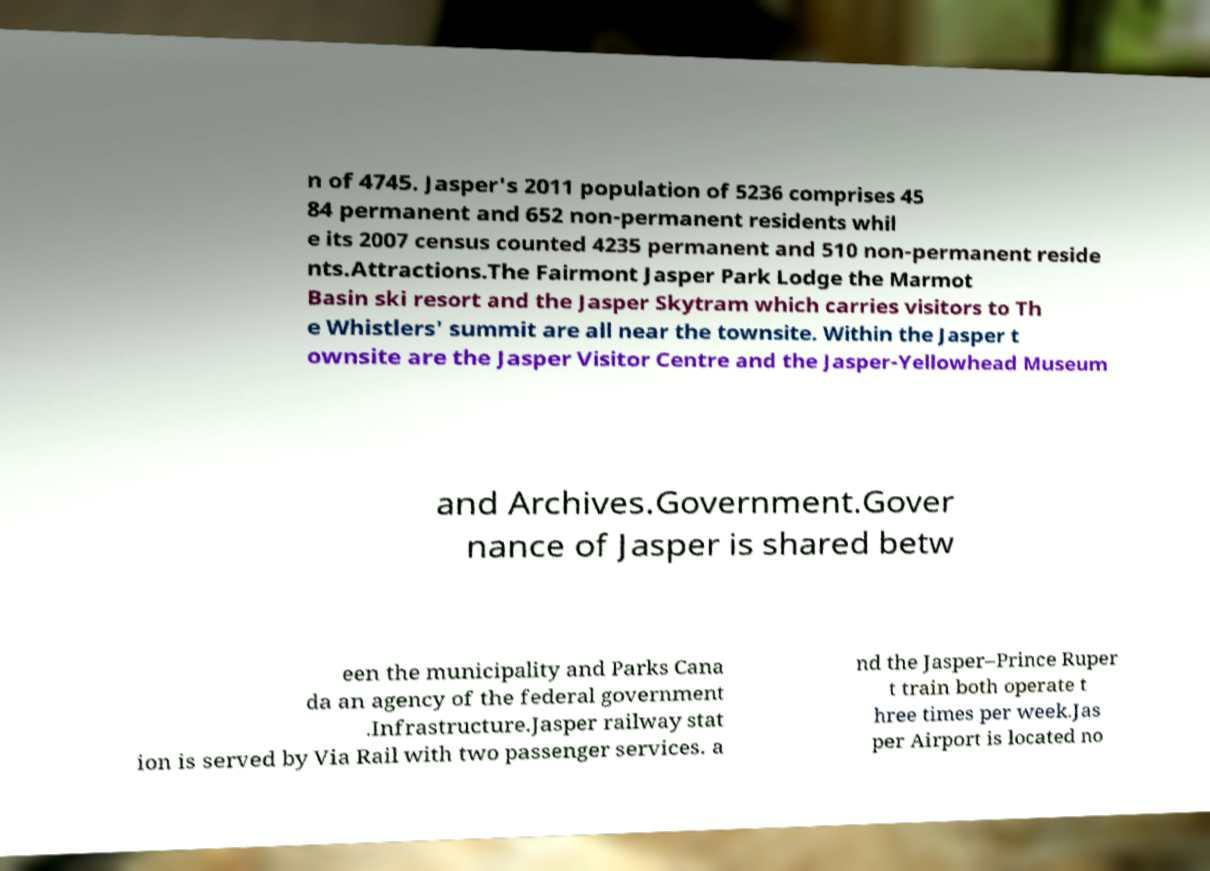What messages or text are displayed in this image? I need them in a readable, typed format. n of 4745. Jasper's 2011 population of 5236 comprises 45 84 permanent and 652 non-permanent residents whil e its 2007 census counted 4235 permanent and 510 non-permanent reside nts.Attractions.The Fairmont Jasper Park Lodge the Marmot Basin ski resort and the Jasper Skytram which carries visitors to Th e Whistlers' summit are all near the townsite. Within the Jasper t ownsite are the Jasper Visitor Centre and the Jasper-Yellowhead Museum and Archives.Government.Gover nance of Jasper is shared betw een the municipality and Parks Cana da an agency of the federal government .Infrastructure.Jasper railway stat ion is served by Via Rail with two passenger services. a nd the Jasper–Prince Ruper t train both operate t hree times per week.Jas per Airport is located no 